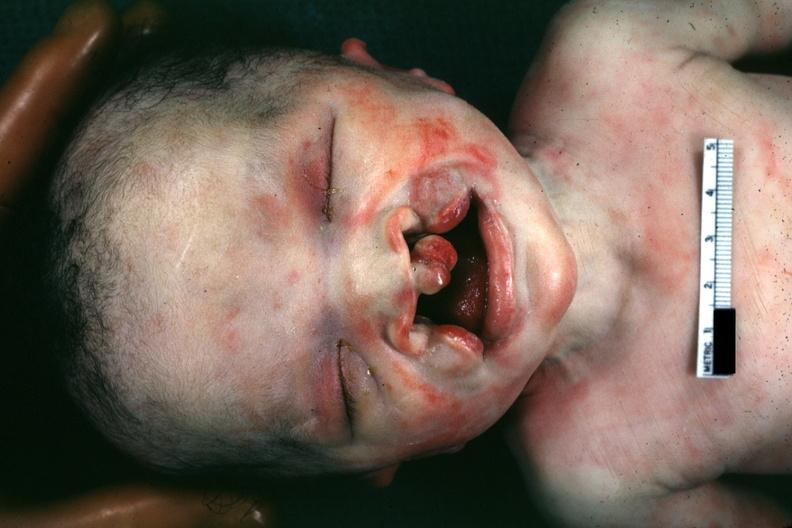what is present?
Answer the question using a single word or phrase. Bilateral cleft palate 